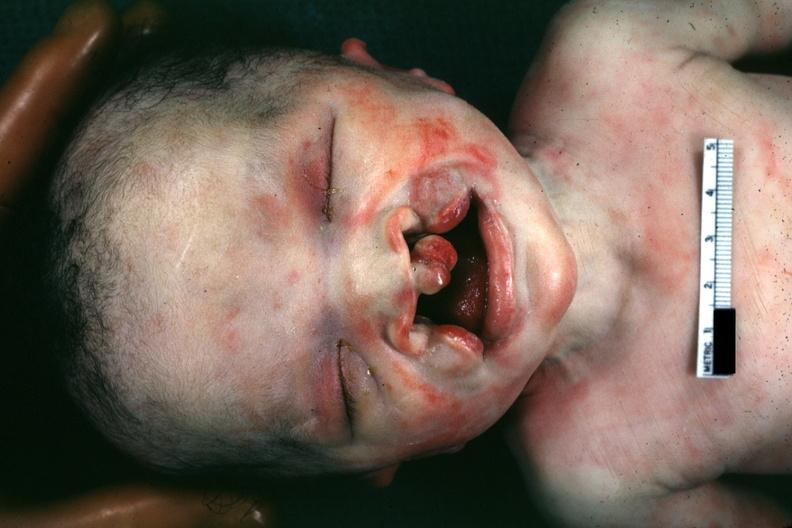what is present?
Answer the question using a single word or phrase. Bilateral cleft palate 